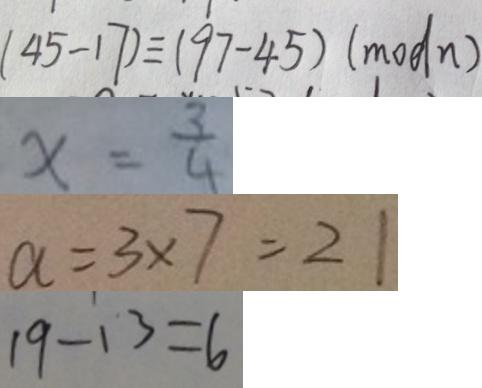Convert formula to latex. <formula><loc_0><loc_0><loc_500><loc_500>( 4 5 - 1 7 ) \equiv ( 9 7 - 4 5 ) ( m o d n ) 
 x = \frac { 3 } { 4 } 
 a = 3 \times 7 = 2 1 
 1 9 - 1 3 = 6</formula> 